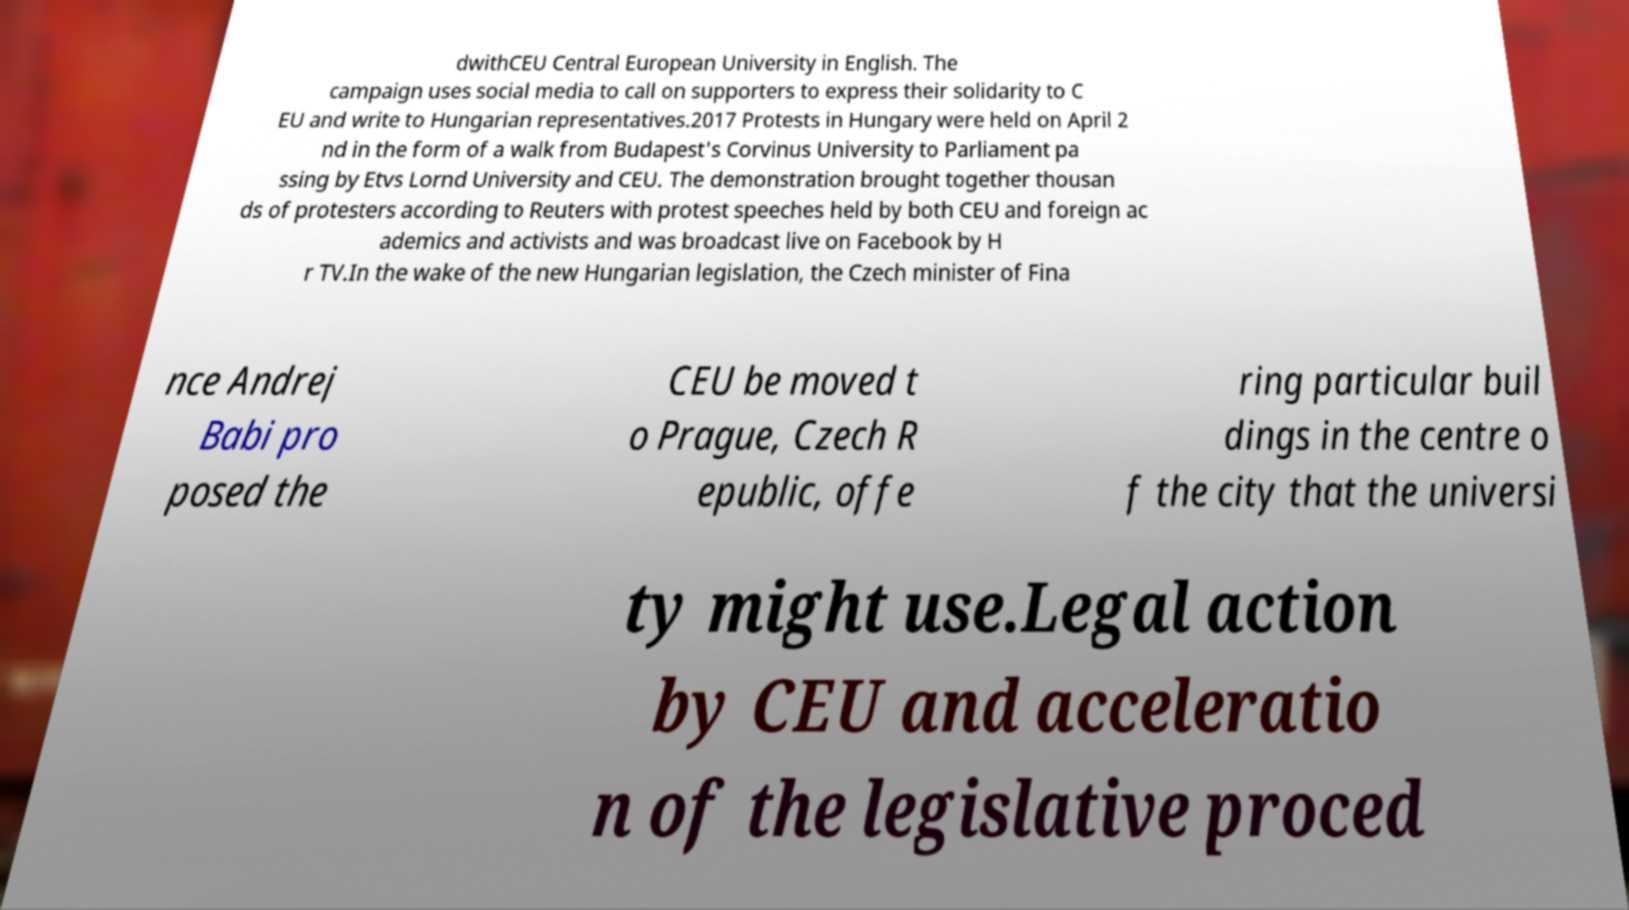Can you read and provide the text displayed in the image?This photo seems to have some interesting text. Can you extract and type it out for me? dwithCEU Central European University in English. The campaign uses social media to call on supporters to express their solidarity to C EU and write to Hungarian representatives.2017 Protests in Hungary were held on April 2 nd in the form of a walk from Budapest's Corvinus University to Parliament pa ssing by Etvs Lornd University and CEU. The demonstration brought together thousan ds of protesters according to Reuters with protest speeches held by both CEU and foreign ac ademics and activists and was broadcast live on Facebook by H r TV.In the wake of the new Hungarian legislation, the Czech minister of Fina nce Andrej Babi pro posed the CEU be moved t o Prague, Czech R epublic, offe ring particular buil dings in the centre o f the city that the universi ty might use.Legal action by CEU and acceleratio n of the legislative proced 